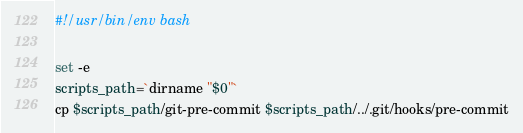Convert code to text. <code><loc_0><loc_0><loc_500><loc_500><_Bash_>#!/usr/bin/env bash

set -e
scripts_path=`dirname "$0"`
cp $scripts_path/git-pre-commit $scripts_path/../.git/hooks/pre-commit
</code> 